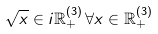Convert formula to latex. <formula><loc_0><loc_0><loc_500><loc_500>\sqrt { x } \in i { \mathbb { R } } ^ { ( 3 ) } _ { + } \, \forall x \in { \mathbb { R } } ^ { ( 3 ) } _ { + }</formula> 